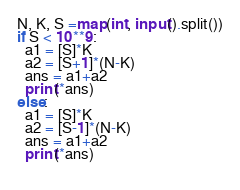Convert code to text. <code><loc_0><loc_0><loc_500><loc_500><_Python_>N, K, S =map(int, input().split())
if S < 10**9:
  a1 = [S]*K
  a2 = [S+1]*(N-K)
  ans = a1+a2
  print(*ans)
else:
  a1 = [S]*K
  a2 = [S-1]*(N-K)
  ans = a1+a2
  print(*ans)
  </code> 